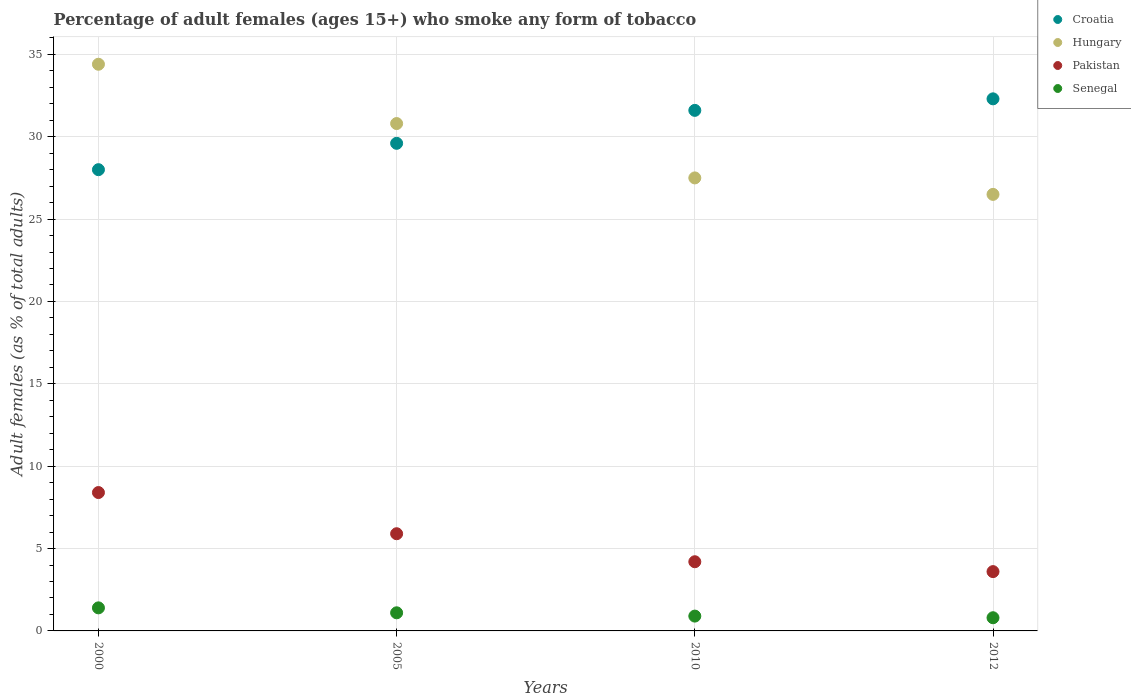Is the number of dotlines equal to the number of legend labels?
Offer a terse response. Yes. What is the percentage of adult females who smoke in Croatia in 2000?
Your answer should be very brief. 28. Across all years, what is the maximum percentage of adult females who smoke in Hungary?
Your answer should be very brief. 34.4. Across all years, what is the minimum percentage of adult females who smoke in Pakistan?
Give a very brief answer. 3.6. What is the total percentage of adult females who smoke in Hungary in the graph?
Provide a short and direct response. 119.2. What is the difference between the percentage of adult females who smoke in Pakistan in 2000 and that in 2012?
Keep it short and to the point. 4.8. What is the difference between the percentage of adult females who smoke in Senegal in 2010 and the percentage of adult females who smoke in Croatia in 2012?
Provide a succinct answer. -31.4. What is the average percentage of adult females who smoke in Croatia per year?
Offer a terse response. 30.38. In the year 2005, what is the difference between the percentage of adult females who smoke in Senegal and percentage of adult females who smoke in Hungary?
Make the answer very short. -29.7. What is the ratio of the percentage of adult females who smoke in Croatia in 2000 to that in 2005?
Offer a terse response. 0.95. What is the difference between the highest and the second highest percentage of adult females who smoke in Croatia?
Provide a succinct answer. 0.7. What is the difference between the highest and the lowest percentage of adult females who smoke in Senegal?
Make the answer very short. 0.6. Is the sum of the percentage of adult females who smoke in Croatia in 2000 and 2012 greater than the maximum percentage of adult females who smoke in Hungary across all years?
Make the answer very short. Yes. Is it the case that in every year, the sum of the percentage of adult females who smoke in Hungary and percentage of adult females who smoke in Senegal  is greater than the sum of percentage of adult females who smoke in Croatia and percentage of adult females who smoke in Pakistan?
Offer a terse response. No. Is it the case that in every year, the sum of the percentage of adult females who smoke in Hungary and percentage of adult females who smoke in Senegal  is greater than the percentage of adult females who smoke in Pakistan?
Your answer should be very brief. Yes. Does the percentage of adult females who smoke in Pakistan monotonically increase over the years?
Offer a terse response. No. Is the percentage of adult females who smoke in Croatia strictly less than the percentage of adult females who smoke in Hungary over the years?
Ensure brevity in your answer.  No. How many dotlines are there?
Provide a short and direct response. 4. How many years are there in the graph?
Provide a succinct answer. 4. Does the graph contain grids?
Provide a succinct answer. Yes. Where does the legend appear in the graph?
Your answer should be compact. Top right. How many legend labels are there?
Provide a succinct answer. 4. How are the legend labels stacked?
Your answer should be compact. Vertical. What is the title of the graph?
Provide a succinct answer. Percentage of adult females (ages 15+) who smoke any form of tobacco. Does "Libya" appear as one of the legend labels in the graph?
Your answer should be compact. No. What is the label or title of the Y-axis?
Your answer should be compact. Adult females (as % of total adults). What is the Adult females (as % of total adults) in Croatia in 2000?
Offer a very short reply. 28. What is the Adult females (as % of total adults) in Hungary in 2000?
Your response must be concise. 34.4. What is the Adult females (as % of total adults) of Pakistan in 2000?
Ensure brevity in your answer.  8.4. What is the Adult females (as % of total adults) of Senegal in 2000?
Your response must be concise. 1.4. What is the Adult females (as % of total adults) of Croatia in 2005?
Provide a short and direct response. 29.6. What is the Adult females (as % of total adults) of Hungary in 2005?
Make the answer very short. 30.8. What is the Adult females (as % of total adults) of Croatia in 2010?
Your answer should be very brief. 31.6. What is the Adult females (as % of total adults) in Croatia in 2012?
Offer a terse response. 32.3. What is the Adult females (as % of total adults) in Senegal in 2012?
Your response must be concise. 0.8. Across all years, what is the maximum Adult females (as % of total adults) of Croatia?
Ensure brevity in your answer.  32.3. Across all years, what is the maximum Adult females (as % of total adults) of Hungary?
Provide a short and direct response. 34.4. Across all years, what is the maximum Adult females (as % of total adults) of Pakistan?
Provide a succinct answer. 8.4. Across all years, what is the minimum Adult females (as % of total adults) in Croatia?
Provide a short and direct response. 28. Across all years, what is the minimum Adult females (as % of total adults) of Hungary?
Offer a very short reply. 26.5. Across all years, what is the minimum Adult females (as % of total adults) in Pakistan?
Provide a succinct answer. 3.6. What is the total Adult females (as % of total adults) in Croatia in the graph?
Your answer should be very brief. 121.5. What is the total Adult females (as % of total adults) in Hungary in the graph?
Offer a very short reply. 119.2. What is the total Adult females (as % of total adults) of Pakistan in the graph?
Your answer should be very brief. 22.1. What is the difference between the Adult females (as % of total adults) of Pakistan in 2000 and that in 2005?
Provide a succinct answer. 2.5. What is the difference between the Adult females (as % of total adults) of Senegal in 2000 and that in 2005?
Your answer should be compact. 0.3. What is the difference between the Adult females (as % of total adults) in Croatia in 2000 and that in 2010?
Your answer should be compact. -3.6. What is the difference between the Adult females (as % of total adults) in Pakistan in 2000 and that in 2010?
Your answer should be very brief. 4.2. What is the difference between the Adult females (as % of total adults) of Senegal in 2000 and that in 2010?
Ensure brevity in your answer.  0.5. What is the difference between the Adult females (as % of total adults) in Croatia in 2000 and that in 2012?
Your response must be concise. -4.3. What is the difference between the Adult females (as % of total adults) of Senegal in 2000 and that in 2012?
Offer a terse response. 0.6. What is the difference between the Adult females (as % of total adults) of Pakistan in 2005 and that in 2010?
Your answer should be compact. 1.7. What is the difference between the Adult females (as % of total adults) of Senegal in 2005 and that in 2012?
Make the answer very short. 0.3. What is the difference between the Adult females (as % of total adults) in Croatia in 2000 and the Adult females (as % of total adults) in Pakistan in 2005?
Your answer should be compact. 22.1. What is the difference between the Adult females (as % of total adults) in Croatia in 2000 and the Adult females (as % of total adults) in Senegal in 2005?
Your answer should be very brief. 26.9. What is the difference between the Adult females (as % of total adults) of Hungary in 2000 and the Adult females (as % of total adults) of Senegal in 2005?
Keep it short and to the point. 33.3. What is the difference between the Adult females (as % of total adults) in Croatia in 2000 and the Adult females (as % of total adults) in Hungary in 2010?
Give a very brief answer. 0.5. What is the difference between the Adult females (as % of total adults) in Croatia in 2000 and the Adult females (as % of total adults) in Pakistan in 2010?
Keep it short and to the point. 23.8. What is the difference between the Adult females (as % of total adults) of Croatia in 2000 and the Adult females (as % of total adults) of Senegal in 2010?
Provide a short and direct response. 27.1. What is the difference between the Adult females (as % of total adults) of Hungary in 2000 and the Adult females (as % of total adults) of Pakistan in 2010?
Your response must be concise. 30.2. What is the difference between the Adult females (as % of total adults) of Hungary in 2000 and the Adult females (as % of total adults) of Senegal in 2010?
Your response must be concise. 33.5. What is the difference between the Adult females (as % of total adults) of Pakistan in 2000 and the Adult females (as % of total adults) of Senegal in 2010?
Provide a succinct answer. 7.5. What is the difference between the Adult females (as % of total adults) of Croatia in 2000 and the Adult females (as % of total adults) of Hungary in 2012?
Make the answer very short. 1.5. What is the difference between the Adult females (as % of total adults) in Croatia in 2000 and the Adult females (as % of total adults) in Pakistan in 2012?
Offer a terse response. 24.4. What is the difference between the Adult females (as % of total adults) of Croatia in 2000 and the Adult females (as % of total adults) of Senegal in 2012?
Your answer should be compact. 27.2. What is the difference between the Adult females (as % of total adults) in Hungary in 2000 and the Adult females (as % of total adults) in Pakistan in 2012?
Your response must be concise. 30.8. What is the difference between the Adult females (as % of total adults) in Hungary in 2000 and the Adult females (as % of total adults) in Senegal in 2012?
Make the answer very short. 33.6. What is the difference between the Adult females (as % of total adults) in Pakistan in 2000 and the Adult females (as % of total adults) in Senegal in 2012?
Make the answer very short. 7.6. What is the difference between the Adult females (as % of total adults) in Croatia in 2005 and the Adult females (as % of total adults) in Pakistan in 2010?
Offer a very short reply. 25.4. What is the difference between the Adult females (as % of total adults) in Croatia in 2005 and the Adult females (as % of total adults) in Senegal in 2010?
Offer a very short reply. 28.7. What is the difference between the Adult females (as % of total adults) of Hungary in 2005 and the Adult females (as % of total adults) of Pakistan in 2010?
Give a very brief answer. 26.6. What is the difference between the Adult females (as % of total adults) in Hungary in 2005 and the Adult females (as % of total adults) in Senegal in 2010?
Provide a succinct answer. 29.9. What is the difference between the Adult females (as % of total adults) of Pakistan in 2005 and the Adult females (as % of total adults) of Senegal in 2010?
Provide a short and direct response. 5. What is the difference between the Adult females (as % of total adults) in Croatia in 2005 and the Adult females (as % of total adults) in Senegal in 2012?
Offer a very short reply. 28.8. What is the difference between the Adult females (as % of total adults) in Hungary in 2005 and the Adult females (as % of total adults) in Pakistan in 2012?
Give a very brief answer. 27.2. What is the difference between the Adult females (as % of total adults) of Hungary in 2005 and the Adult females (as % of total adults) of Senegal in 2012?
Give a very brief answer. 30. What is the difference between the Adult females (as % of total adults) of Croatia in 2010 and the Adult females (as % of total adults) of Hungary in 2012?
Your response must be concise. 5.1. What is the difference between the Adult females (as % of total adults) of Croatia in 2010 and the Adult females (as % of total adults) of Pakistan in 2012?
Offer a terse response. 28. What is the difference between the Adult females (as % of total adults) of Croatia in 2010 and the Adult females (as % of total adults) of Senegal in 2012?
Offer a terse response. 30.8. What is the difference between the Adult females (as % of total adults) of Hungary in 2010 and the Adult females (as % of total adults) of Pakistan in 2012?
Offer a very short reply. 23.9. What is the difference between the Adult females (as % of total adults) of Hungary in 2010 and the Adult females (as % of total adults) of Senegal in 2012?
Your answer should be very brief. 26.7. What is the average Adult females (as % of total adults) of Croatia per year?
Give a very brief answer. 30.38. What is the average Adult females (as % of total adults) of Hungary per year?
Ensure brevity in your answer.  29.8. What is the average Adult females (as % of total adults) of Pakistan per year?
Offer a terse response. 5.53. What is the average Adult females (as % of total adults) in Senegal per year?
Give a very brief answer. 1.05. In the year 2000, what is the difference between the Adult females (as % of total adults) in Croatia and Adult females (as % of total adults) in Pakistan?
Offer a terse response. 19.6. In the year 2000, what is the difference between the Adult females (as % of total adults) in Croatia and Adult females (as % of total adults) in Senegal?
Give a very brief answer. 26.6. In the year 2000, what is the difference between the Adult females (as % of total adults) in Hungary and Adult females (as % of total adults) in Pakistan?
Keep it short and to the point. 26. In the year 2005, what is the difference between the Adult females (as % of total adults) of Croatia and Adult females (as % of total adults) of Hungary?
Provide a short and direct response. -1.2. In the year 2005, what is the difference between the Adult females (as % of total adults) of Croatia and Adult females (as % of total adults) of Pakistan?
Keep it short and to the point. 23.7. In the year 2005, what is the difference between the Adult females (as % of total adults) of Hungary and Adult females (as % of total adults) of Pakistan?
Ensure brevity in your answer.  24.9. In the year 2005, what is the difference between the Adult females (as % of total adults) of Hungary and Adult females (as % of total adults) of Senegal?
Provide a short and direct response. 29.7. In the year 2010, what is the difference between the Adult females (as % of total adults) in Croatia and Adult females (as % of total adults) in Pakistan?
Make the answer very short. 27.4. In the year 2010, what is the difference between the Adult females (as % of total adults) in Croatia and Adult females (as % of total adults) in Senegal?
Provide a succinct answer. 30.7. In the year 2010, what is the difference between the Adult females (as % of total adults) of Hungary and Adult females (as % of total adults) of Pakistan?
Keep it short and to the point. 23.3. In the year 2010, what is the difference between the Adult females (as % of total adults) in Hungary and Adult females (as % of total adults) in Senegal?
Your answer should be compact. 26.6. In the year 2010, what is the difference between the Adult females (as % of total adults) in Pakistan and Adult females (as % of total adults) in Senegal?
Provide a short and direct response. 3.3. In the year 2012, what is the difference between the Adult females (as % of total adults) of Croatia and Adult females (as % of total adults) of Pakistan?
Ensure brevity in your answer.  28.7. In the year 2012, what is the difference between the Adult females (as % of total adults) of Croatia and Adult females (as % of total adults) of Senegal?
Your answer should be very brief. 31.5. In the year 2012, what is the difference between the Adult females (as % of total adults) of Hungary and Adult females (as % of total adults) of Pakistan?
Offer a terse response. 22.9. In the year 2012, what is the difference between the Adult females (as % of total adults) in Hungary and Adult females (as % of total adults) in Senegal?
Provide a succinct answer. 25.7. In the year 2012, what is the difference between the Adult females (as % of total adults) in Pakistan and Adult females (as % of total adults) in Senegal?
Your answer should be compact. 2.8. What is the ratio of the Adult females (as % of total adults) in Croatia in 2000 to that in 2005?
Give a very brief answer. 0.95. What is the ratio of the Adult females (as % of total adults) in Hungary in 2000 to that in 2005?
Offer a very short reply. 1.12. What is the ratio of the Adult females (as % of total adults) of Pakistan in 2000 to that in 2005?
Provide a short and direct response. 1.42. What is the ratio of the Adult females (as % of total adults) in Senegal in 2000 to that in 2005?
Offer a very short reply. 1.27. What is the ratio of the Adult females (as % of total adults) of Croatia in 2000 to that in 2010?
Provide a succinct answer. 0.89. What is the ratio of the Adult females (as % of total adults) of Hungary in 2000 to that in 2010?
Provide a short and direct response. 1.25. What is the ratio of the Adult females (as % of total adults) of Senegal in 2000 to that in 2010?
Offer a very short reply. 1.56. What is the ratio of the Adult females (as % of total adults) of Croatia in 2000 to that in 2012?
Your answer should be very brief. 0.87. What is the ratio of the Adult females (as % of total adults) of Hungary in 2000 to that in 2012?
Make the answer very short. 1.3. What is the ratio of the Adult females (as % of total adults) in Pakistan in 2000 to that in 2012?
Keep it short and to the point. 2.33. What is the ratio of the Adult females (as % of total adults) in Senegal in 2000 to that in 2012?
Ensure brevity in your answer.  1.75. What is the ratio of the Adult females (as % of total adults) in Croatia in 2005 to that in 2010?
Your answer should be very brief. 0.94. What is the ratio of the Adult females (as % of total adults) in Hungary in 2005 to that in 2010?
Give a very brief answer. 1.12. What is the ratio of the Adult females (as % of total adults) in Pakistan in 2005 to that in 2010?
Ensure brevity in your answer.  1.4. What is the ratio of the Adult females (as % of total adults) in Senegal in 2005 to that in 2010?
Your answer should be very brief. 1.22. What is the ratio of the Adult females (as % of total adults) in Croatia in 2005 to that in 2012?
Ensure brevity in your answer.  0.92. What is the ratio of the Adult females (as % of total adults) in Hungary in 2005 to that in 2012?
Your answer should be very brief. 1.16. What is the ratio of the Adult females (as % of total adults) in Pakistan in 2005 to that in 2012?
Offer a terse response. 1.64. What is the ratio of the Adult females (as % of total adults) of Senegal in 2005 to that in 2012?
Provide a short and direct response. 1.38. What is the ratio of the Adult females (as % of total adults) of Croatia in 2010 to that in 2012?
Your response must be concise. 0.98. What is the ratio of the Adult females (as % of total adults) in Hungary in 2010 to that in 2012?
Your response must be concise. 1.04. What is the ratio of the Adult females (as % of total adults) of Pakistan in 2010 to that in 2012?
Keep it short and to the point. 1.17. What is the difference between the highest and the second highest Adult females (as % of total adults) in Senegal?
Ensure brevity in your answer.  0.3. What is the difference between the highest and the lowest Adult females (as % of total adults) in Croatia?
Give a very brief answer. 4.3. 